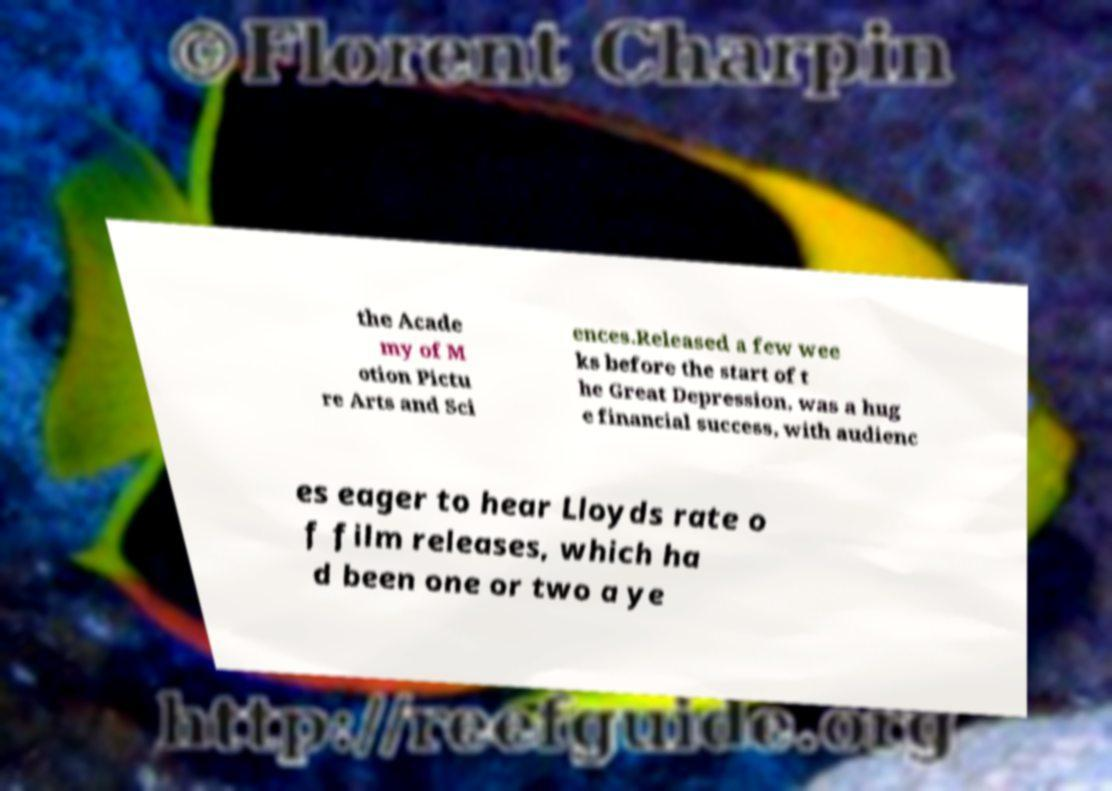Could you extract and type out the text from this image? the Acade my of M otion Pictu re Arts and Sci ences.Released a few wee ks before the start of t he Great Depression, was a hug e financial success, with audienc es eager to hear Lloyds rate o f film releases, which ha d been one or two a ye 